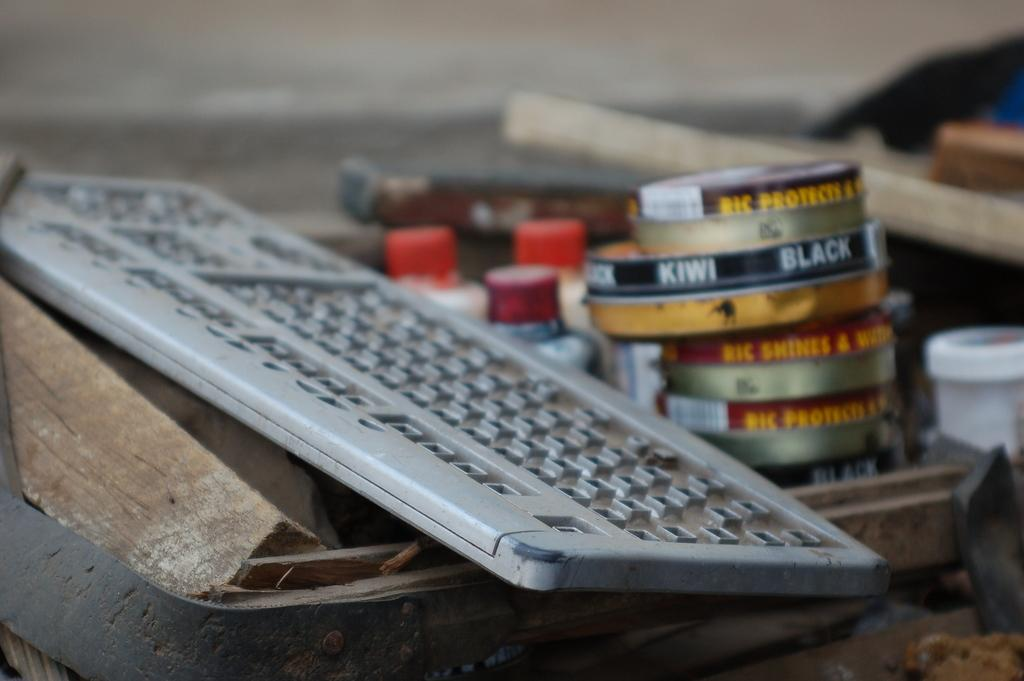<image>
Offer a succinct explanation of the picture presented. a computer keyboard next to canisters of Kiwi Black shoepolish 